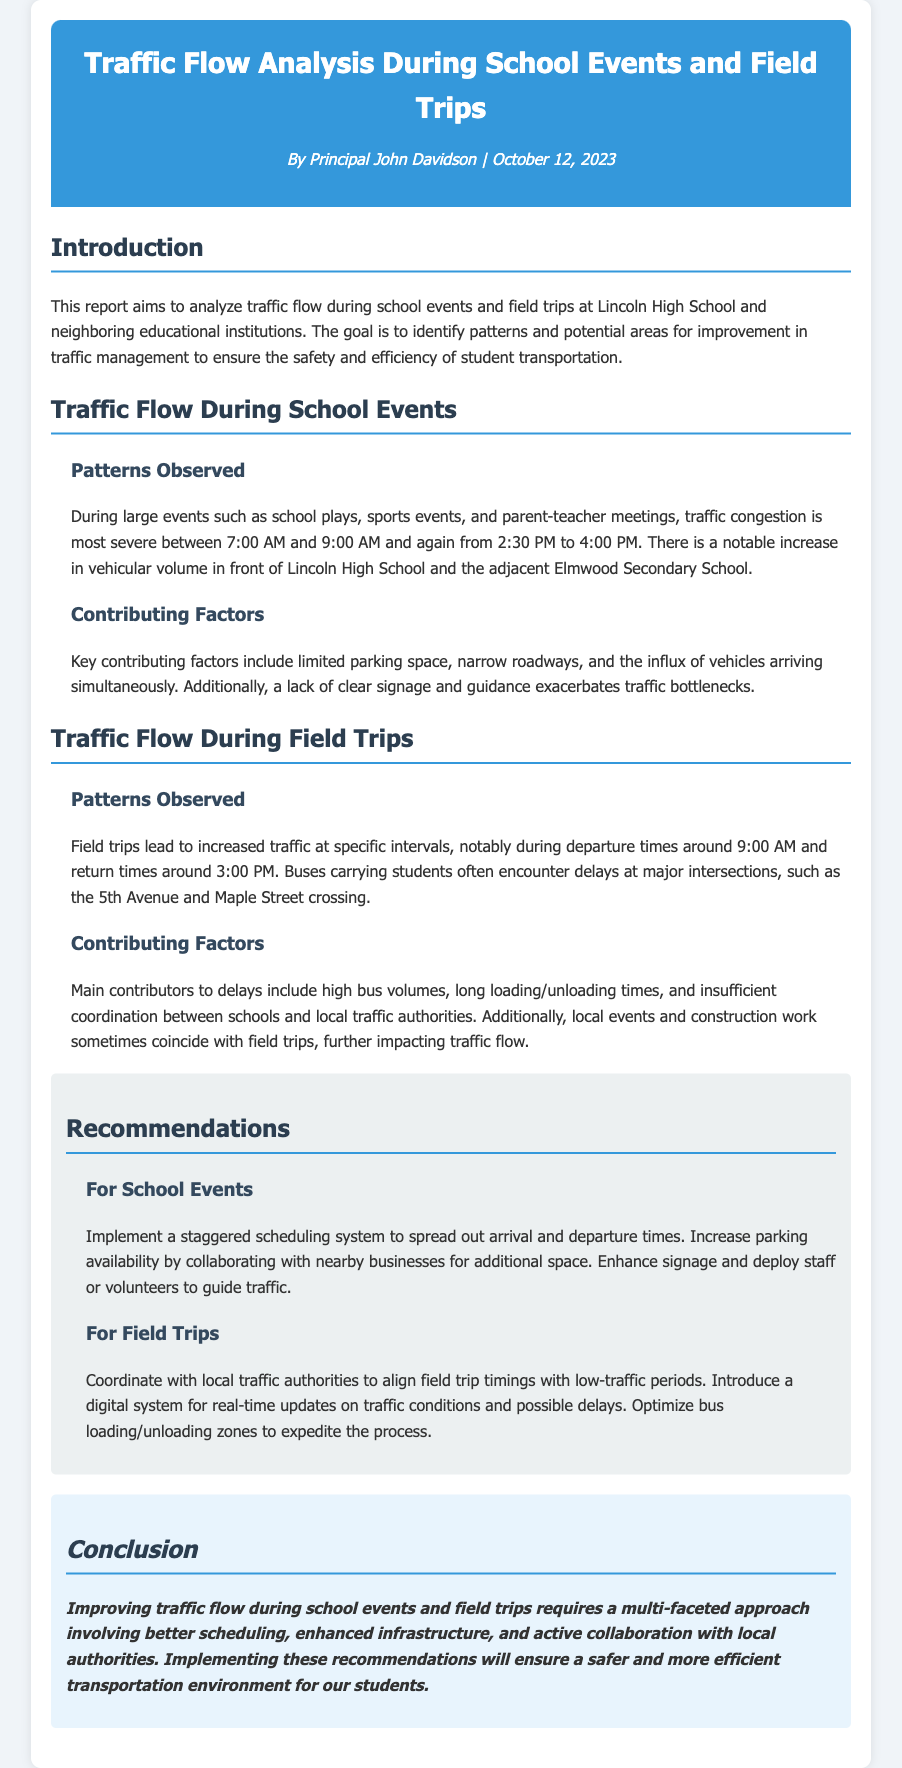What is the title of the report? The title of the report is prominently displayed at the top of the document.
Answer: Traffic Flow Analysis During School Events and Field Trips Who is the author of the report? The author information is provided under the title in the document.
Answer: Principal John Davidson When was the report published? The publication date is located beneath the author's name.
Answer: October 12, 2023 What time do traffic congestions mainly occur during school events? The document lists specific times when traffic congestion is most severe.
Answer: 7:00 AM to 9:00 AM and 2:30 PM to 4:00 PM What is a key contributing factor to traffic delays during field trips? The report outlines several contributing factors to delays during field trips.
Answer: High bus volumes What recommendation is made for school events? The recommendations section suggests actions to improve traffic flow during events.
Answer: Implement a staggered scheduling system What time do field trips typically depart? The document specifies the usual departure time for field trips.
Answer: 9:00 AM What intersection is mentioned as problematic during field trips? The document identifies a specific crossing where delays occur.
Answer: 5th Avenue and Maple Street What does the report emphasize as essential for improving traffic flow? The conclusion highlights a particular approach needed for improvement.
Answer: Multi-faceted approach 